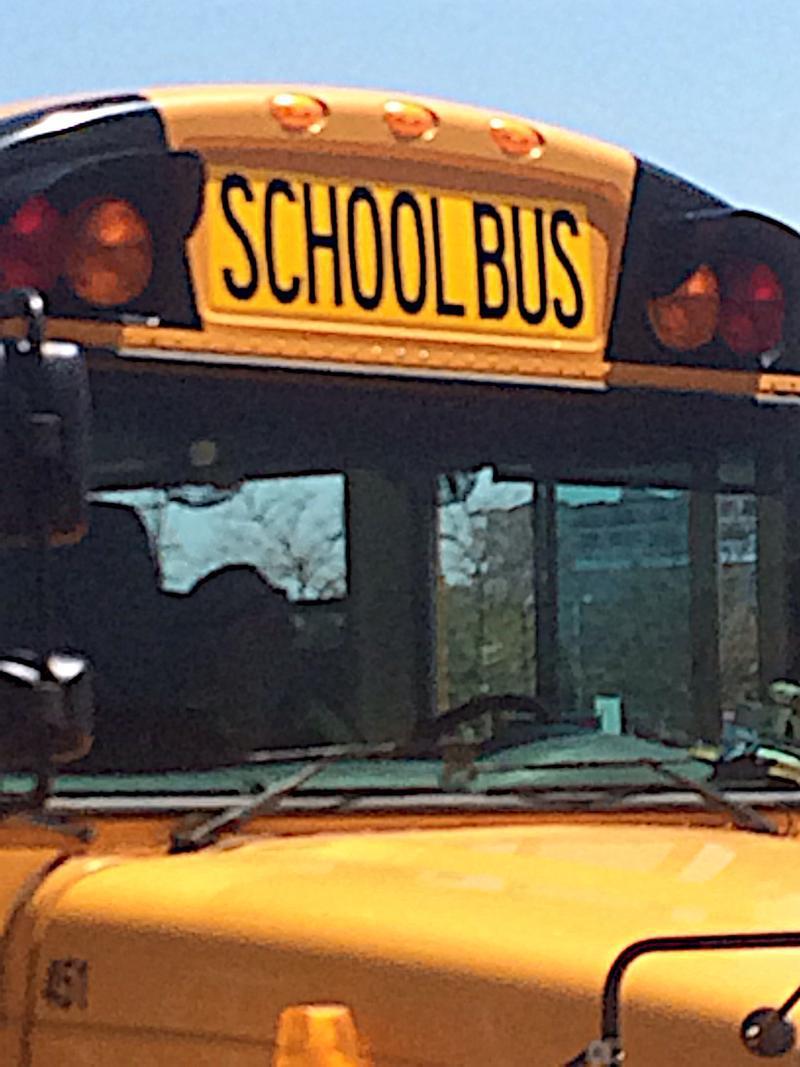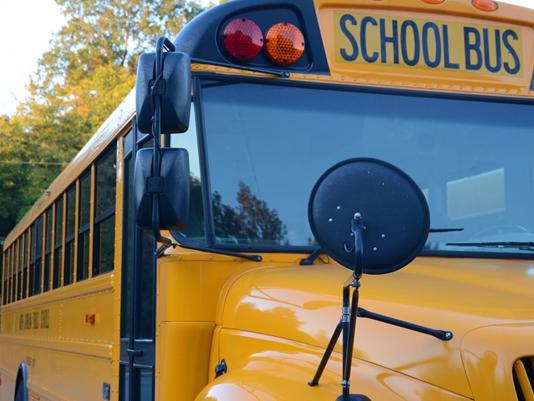The first image is the image on the left, the second image is the image on the right. Examine the images to the left and right. Is the description "Two rectangular rear view mirrors are visible in the righthand image but neither are located on the right side of the image." accurate? Answer yes or no. Yes. The first image is the image on the left, the second image is the image on the right. For the images shown, is this caption "There are exactly two buses." true? Answer yes or no. Yes. 